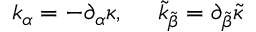Convert formula to latex. <formula><loc_0><loc_0><loc_500><loc_500>k _ { \alpha } = - \partial _ { \alpha } \kappa , \quad \tilde { k } _ { \tilde { \beta } } = \partial _ { \tilde { \beta } } \tilde { \kappa }</formula> 